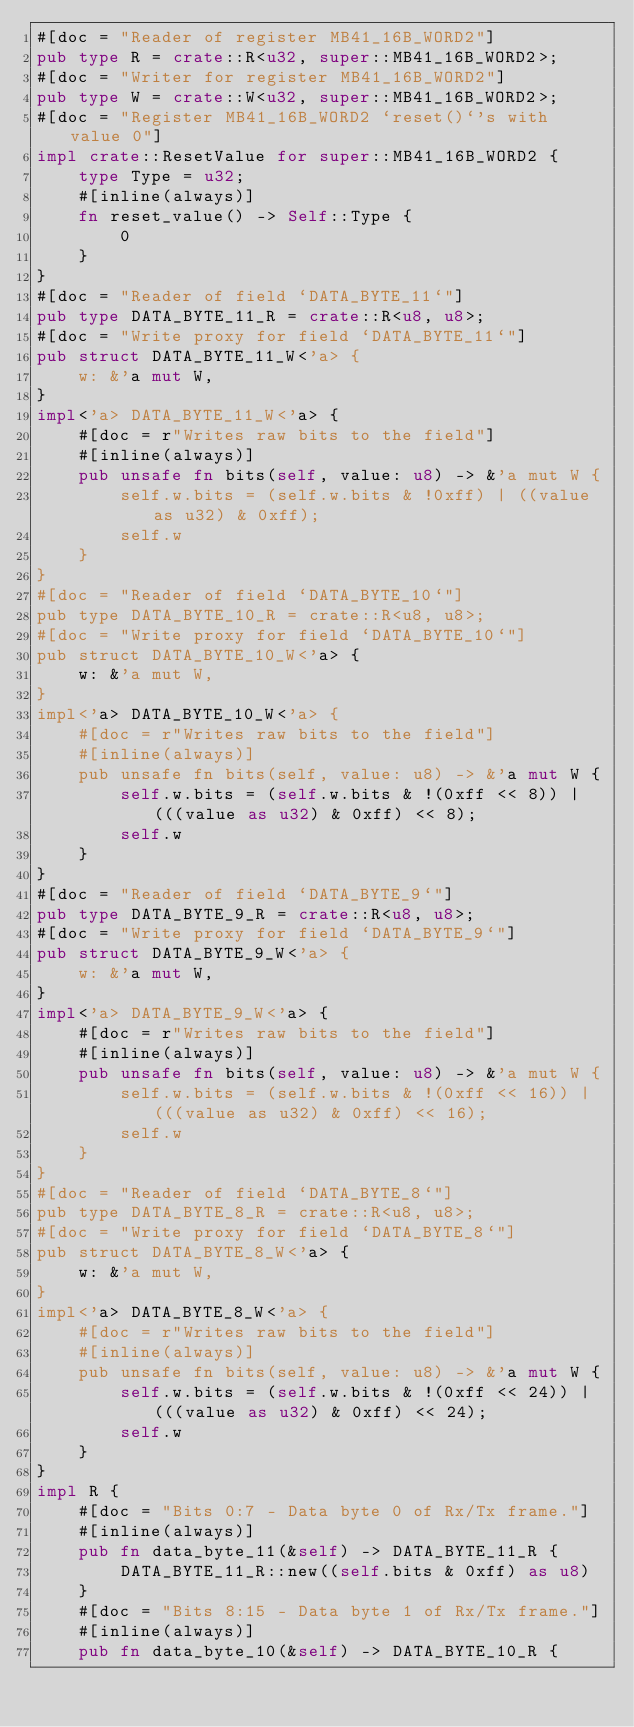<code> <loc_0><loc_0><loc_500><loc_500><_Rust_>#[doc = "Reader of register MB41_16B_WORD2"]
pub type R = crate::R<u32, super::MB41_16B_WORD2>;
#[doc = "Writer for register MB41_16B_WORD2"]
pub type W = crate::W<u32, super::MB41_16B_WORD2>;
#[doc = "Register MB41_16B_WORD2 `reset()`'s with value 0"]
impl crate::ResetValue for super::MB41_16B_WORD2 {
    type Type = u32;
    #[inline(always)]
    fn reset_value() -> Self::Type {
        0
    }
}
#[doc = "Reader of field `DATA_BYTE_11`"]
pub type DATA_BYTE_11_R = crate::R<u8, u8>;
#[doc = "Write proxy for field `DATA_BYTE_11`"]
pub struct DATA_BYTE_11_W<'a> {
    w: &'a mut W,
}
impl<'a> DATA_BYTE_11_W<'a> {
    #[doc = r"Writes raw bits to the field"]
    #[inline(always)]
    pub unsafe fn bits(self, value: u8) -> &'a mut W {
        self.w.bits = (self.w.bits & !0xff) | ((value as u32) & 0xff);
        self.w
    }
}
#[doc = "Reader of field `DATA_BYTE_10`"]
pub type DATA_BYTE_10_R = crate::R<u8, u8>;
#[doc = "Write proxy for field `DATA_BYTE_10`"]
pub struct DATA_BYTE_10_W<'a> {
    w: &'a mut W,
}
impl<'a> DATA_BYTE_10_W<'a> {
    #[doc = r"Writes raw bits to the field"]
    #[inline(always)]
    pub unsafe fn bits(self, value: u8) -> &'a mut W {
        self.w.bits = (self.w.bits & !(0xff << 8)) | (((value as u32) & 0xff) << 8);
        self.w
    }
}
#[doc = "Reader of field `DATA_BYTE_9`"]
pub type DATA_BYTE_9_R = crate::R<u8, u8>;
#[doc = "Write proxy for field `DATA_BYTE_9`"]
pub struct DATA_BYTE_9_W<'a> {
    w: &'a mut W,
}
impl<'a> DATA_BYTE_9_W<'a> {
    #[doc = r"Writes raw bits to the field"]
    #[inline(always)]
    pub unsafe fn bits(self, value: u8) -> &'a mut W {
        self.w.bits = (self.w.bits & !(0xff << 16)) | (((value as u32) & 0xff) << 16);
        self.w
    }
}
#[doc = "Reader of field `DATA_BYTE_8`"]
pub type DATA_BYTE_8_R = crate::R<u8, u8>;
#[doc = "Write proxy for field `DATA_BYTE_8`"]
pub struct DATA_BYTE_8_W<'a> {
    w: &'a mut W,
}
impl<'a> DATA_BYTE_8_W<'a> {
    #[doc = r"Writes raw bits to the field"]
    #[inline(always)]
    pub unsafe fn bits(self, value: u8) -> &'a mut W {
        self.w.bits = (self.w.bits & !(0xff << 24)) | (((value as u32) & 0xff) << 24);
        self.w
    }
}
impl R {
    #[doc = "Bits 0:7 - Data byte 0 of Rx/Tx frame."]
    #[inline(always)]
    pub fn data_byte_11(&self) -> DATA_BYTE_11_R {
        DATA_BYTE_11_R::new((self.bits & 0xff) as u8)
    }
    #[doc = "Bits 8:15 - Data byte 1 of Rx/Tx frame."]
    #[inline(always)]
    pub fn data_byte_10(&self) -> DATA_BYTE_10_R {</code> 